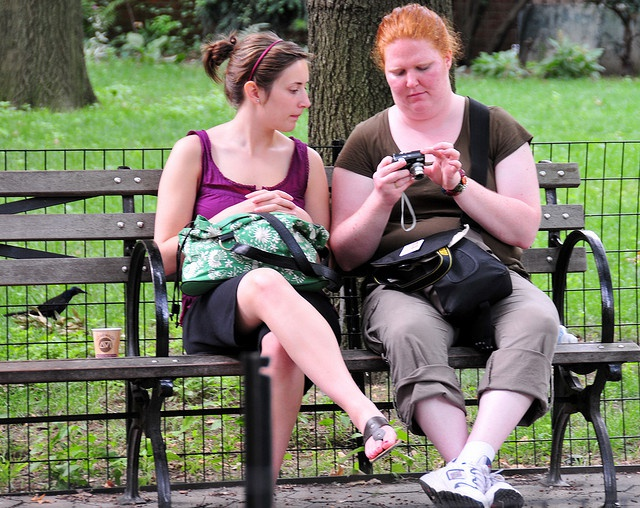Describe the objects in this image and their specific colors. I can see people in gray, black, lavender, and darkgray tones, bench in gray, black, darkgray, and lightgreen tones, people in gray, pink, lightpink, black, and brown tones, handbag in gray, black, white, and turquoise tones, and handbag in gray and black tones in this image. 